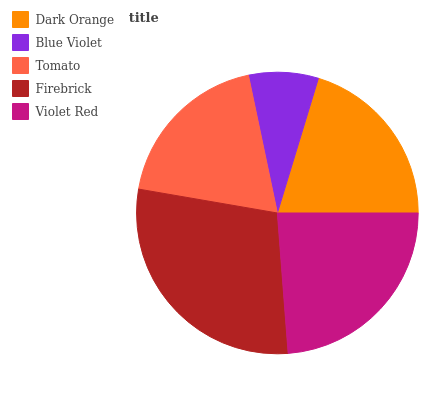Is Blue Violet the minimum?
Answer yes or no. Yes. Is Firebrick the maximum?
Answer yes or no. Yes. Is Tomato the minimum?
Answer yes or no. No. Is Tomato the maximum?
Answer yes or no. No. Is Tomato greater than Blue Violet?
Answer yes or no. Yes. Is Blue Violet less than Tomato?
Answer yes or no. Yes. Is Blue Violet greater than Tomato?
Answer yes or no. No. Is Tomato less than Blue Violet?
Answer yes or no. No. Is Dark Orange the high median?
Answer yes or no. Yes. Is Dark Orange the low median?
Answer yes or no. Yes. Is Blue Violet the high median?
Answer yes or no. No. Is Violet Red the low median?
Answer yes or no. No. 